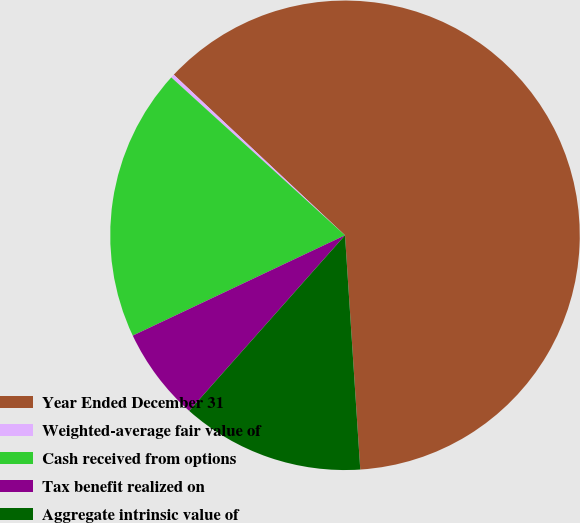Convert chart to OTSL. <chart><loc_0><loc_0><loc_500><loc_500><pie_chart><fcel>Year Ended December 31<fcel>Weighted-average fair value of<fcel>Cash received from options<fcel>Tax benefit realized on<fcel>Aggregate intrinsic value of<nl><fcel>61.98%<fcel>0.25%<fcel>18.77%<fcel>6.42%<fcel>12.59%<nl></chart> 